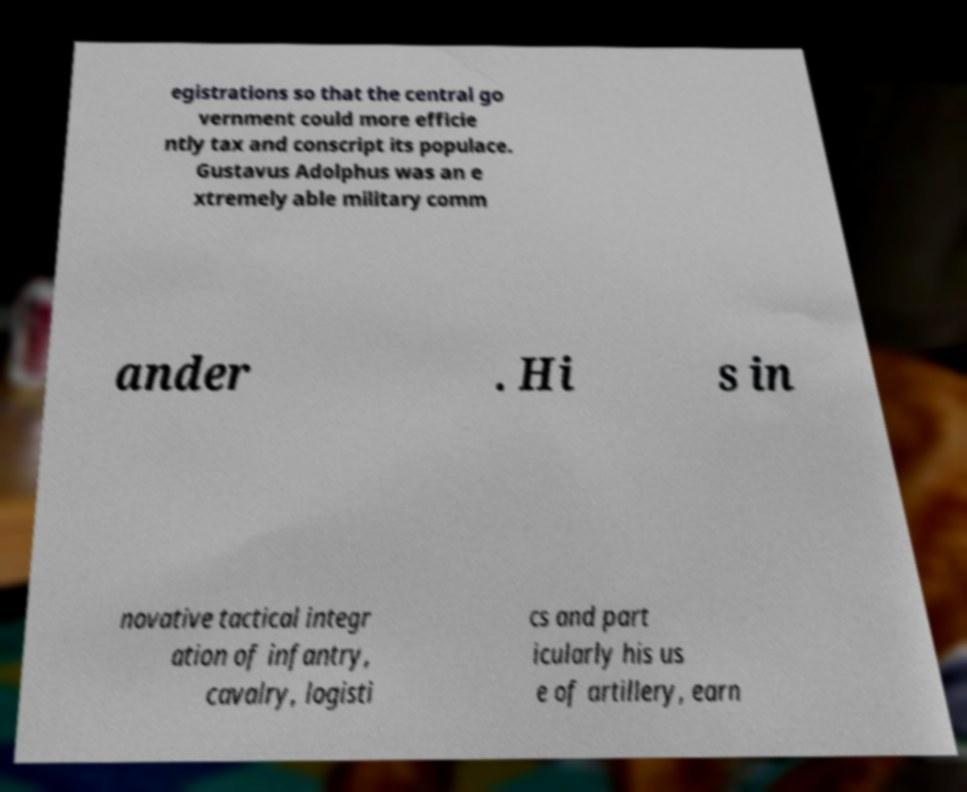Can you accurately transcribe the text from the provided image for me? egistrations so that the central go vernment could more efficie ntly tax and conscript its populace. Gustavus Adolphus was an e xtremely able military comm ander . Hi s in novative tactical integr ation of infantry, cavalry, logisti cs and part icularly his us e of artillery, earn 